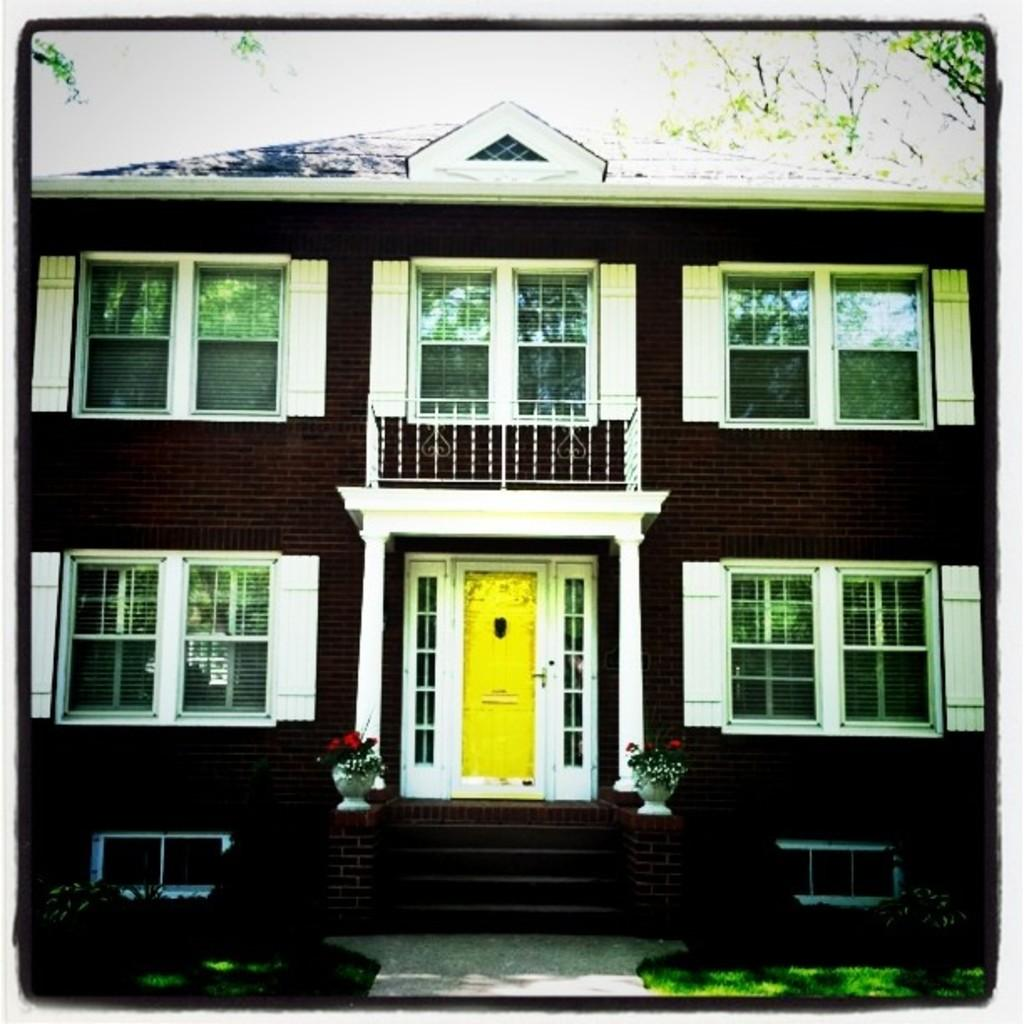What type of structures are depicted in the images in the picture? There are pictures of buildings in the image. What can be seen in the image besides the pictures of buildings? There are grills, houseplants, stairs, shrubs, trees, and the sky visible in the image. What type of amusement can be seen in the image? There is no amusement present in the image; it features pictures of buildings, grills, houseplants, stairs, shrubs, trees, and the sky. Is there any blood visible in the image? There is no blood present in the image. 